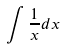Convert formula to latex. <formula><loc_0><loc_0><loc_500><loc_500>\int \frac { 1 } { x } d x</formula> 